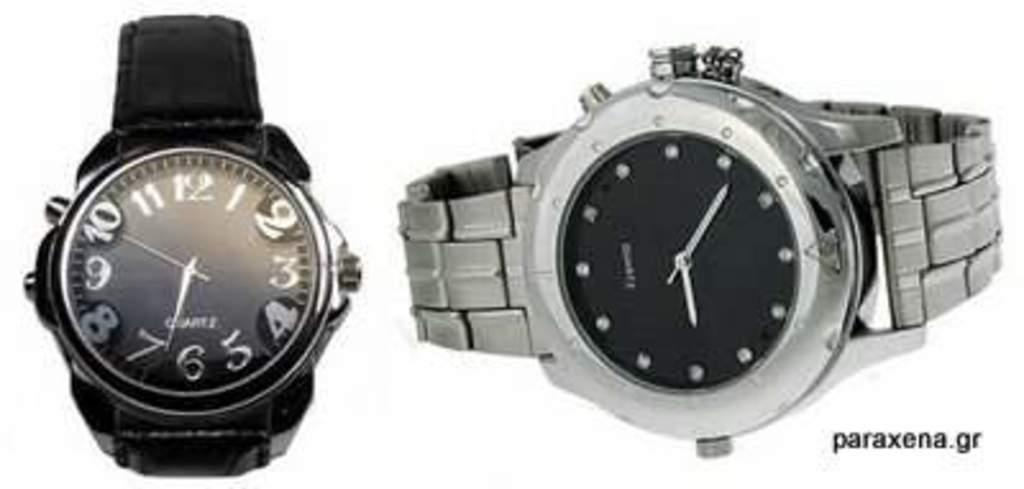<image>
Share a concise interpretation of the image provided. Two wristwatches next to one another with one where the hands are on the numbers 10 and 7. 